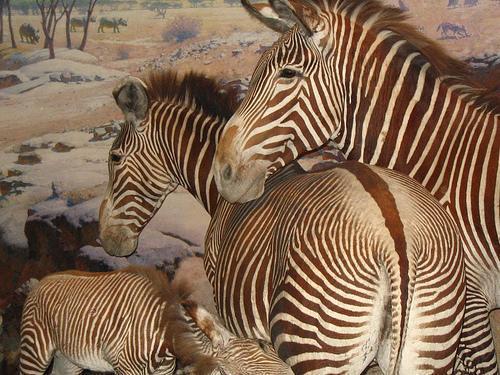How many zebras are there?
Give a very brief answer. 3. How many zebras can be seen?
Give a very brief answer. 3. 